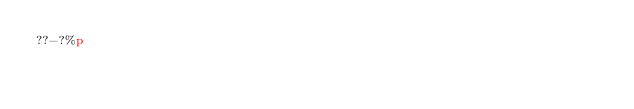Convert code to text. <code><loc_0><loc_0><loc_500><loc_500><_dc_>??-?%p</code> 